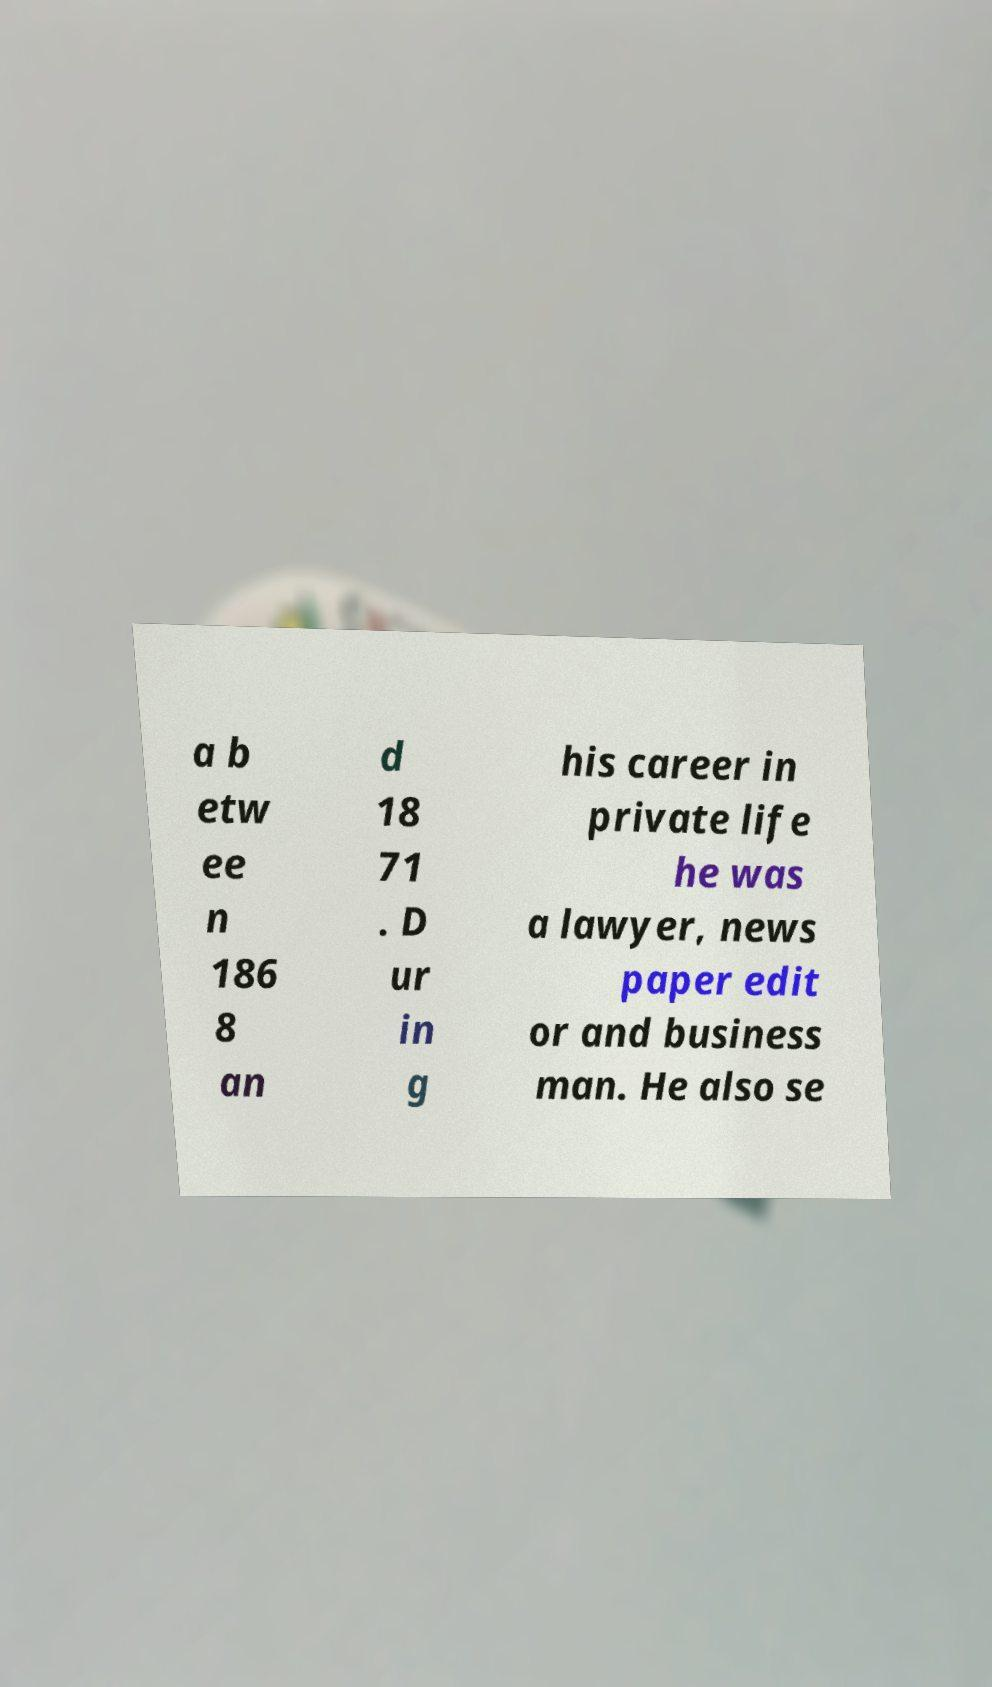There's text embedded in this image that I need extracted. Can you transcribe it verbatim? a b etw ee n 186 8 an d 18 71 . D ur in g his career in private life he was a lawyer, news paper edit or and business man. He also se 